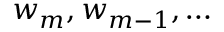<formula> <loc_0><loc_0><loc_500><loc_500>w _ { m } , w _ { m - 1 } , \dots</formula> 